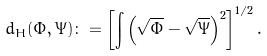Convert formula to latex. <formula><loc_0><loc_0><loc_500><loc_500>d _ { H } ( \Phi , \Psi ) \colon = \left [ \int \left ( \sqrt { \Phi } - \sqrt { \Psi } \right ) ^ { 2 } \right ] ^ { 1 / 2 } .</formula> 